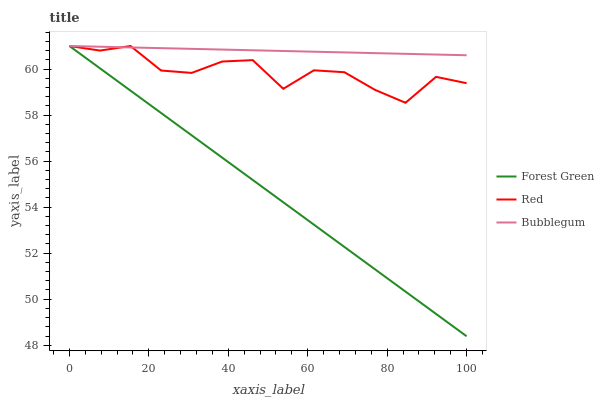Does Forest Green have the minimum area under the curve?
Answer yes or no. Yes. Does Bubblegum have the maximum area under the curve?
Answer yes or no. Yes. Does Red have the minimum area under the curve?
Answer yes or no. No. Does Red have the maximum area under the curve?
Answer yes or no. No. Is Forest Green the smoothest?
Answer yes or no. Yes. Is Red the roughest?
Answer yes or no. Yes. Is Bubblegum the smoothest?
Answer yes or no. No. Is Bubblegum the roughest?
Answer yes or no. No. Does Red have the lowest value?
Answer yes or no. No. Does Red have the highest value?
Answer yes or no. Yes. Does Forest Green intersect Red?
Answer yes or no. Yes. Is Forest Green less than Red?
Answer yes or no. No. Is Forest Green greater than Red?
Answer yes or no. No. 